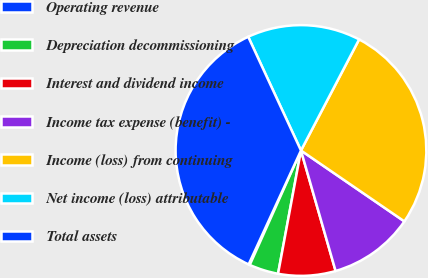<chart> <loc_0><loc_0><loc_500><loc_500><pie_chart><fcel>Operating revenue<fcel>Depreciation decommissioning<fcel>Interest and dividend income<fcel>Income tax expense (benefit) -<fcel>Income (loss) from continuing<fcel>Net income (loss) attributable<fcel>Total assets<nl><fcel>0.16%<fcel>3.77%<fcel>7.38%<fcel>10.98%<fcel>26.89%<fcel>14.59%<fcel>36.23%<nl></chart> 